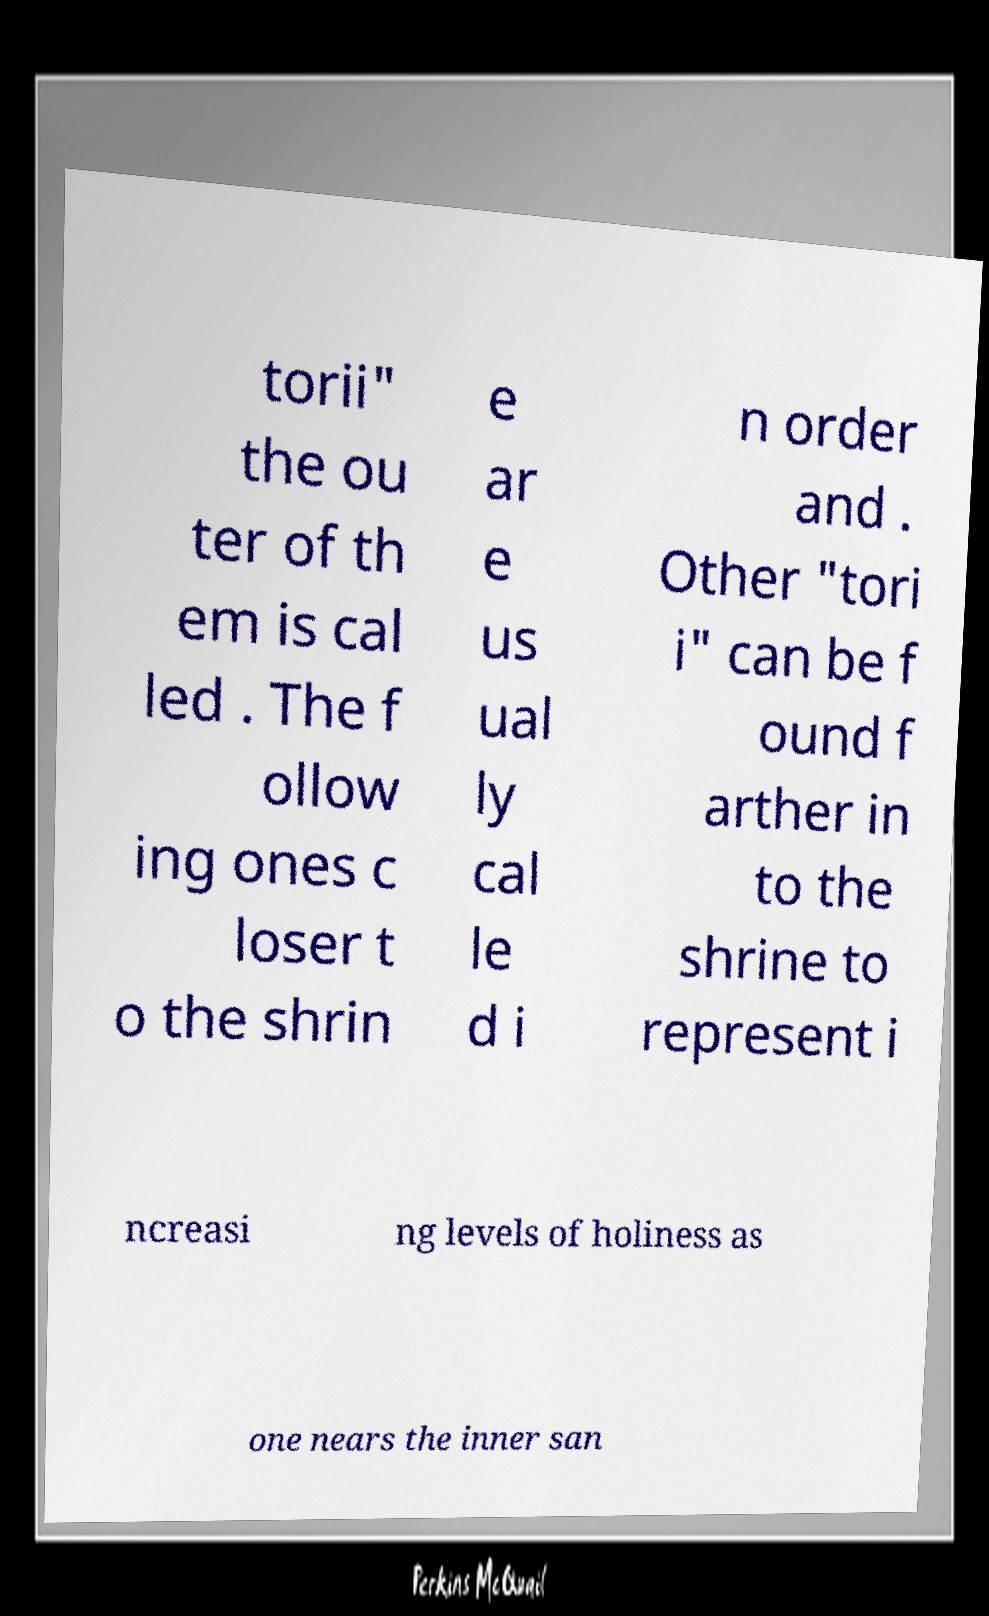Please read and relay the text visible in this image. What does it say? torii" the ou ter of th em is cal led . The f ollow ing ones c loser t o the shrin e ar e us ual ly cal le d i n order and . Other "tori i" can be f ound f arther in to the shrine to represent i ncreasi ng levels of holiness as one nears the inner san 